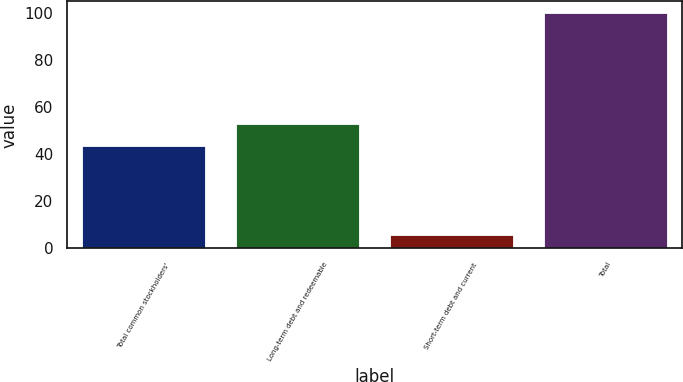<chart> <loc_0><loc_0><loc_500><loc_500><bar_chart><fcel>Total common stockholders'<fcel>Long-term debt and redeemable<fcel>Short-term debt and current<fcel>Total<nl><fcel>43.5<fcel>52.91<fcel>5.9<fcel>100<nl></chart> 